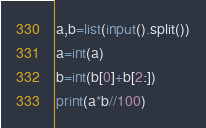Convert code to text. <code><loc_0><loc_0><loc_500><loc_500><_Python_>a,b=list(input().split())
a=int(a)
b=int(b[0]+b[2:])
print(a*b//100)</code> 